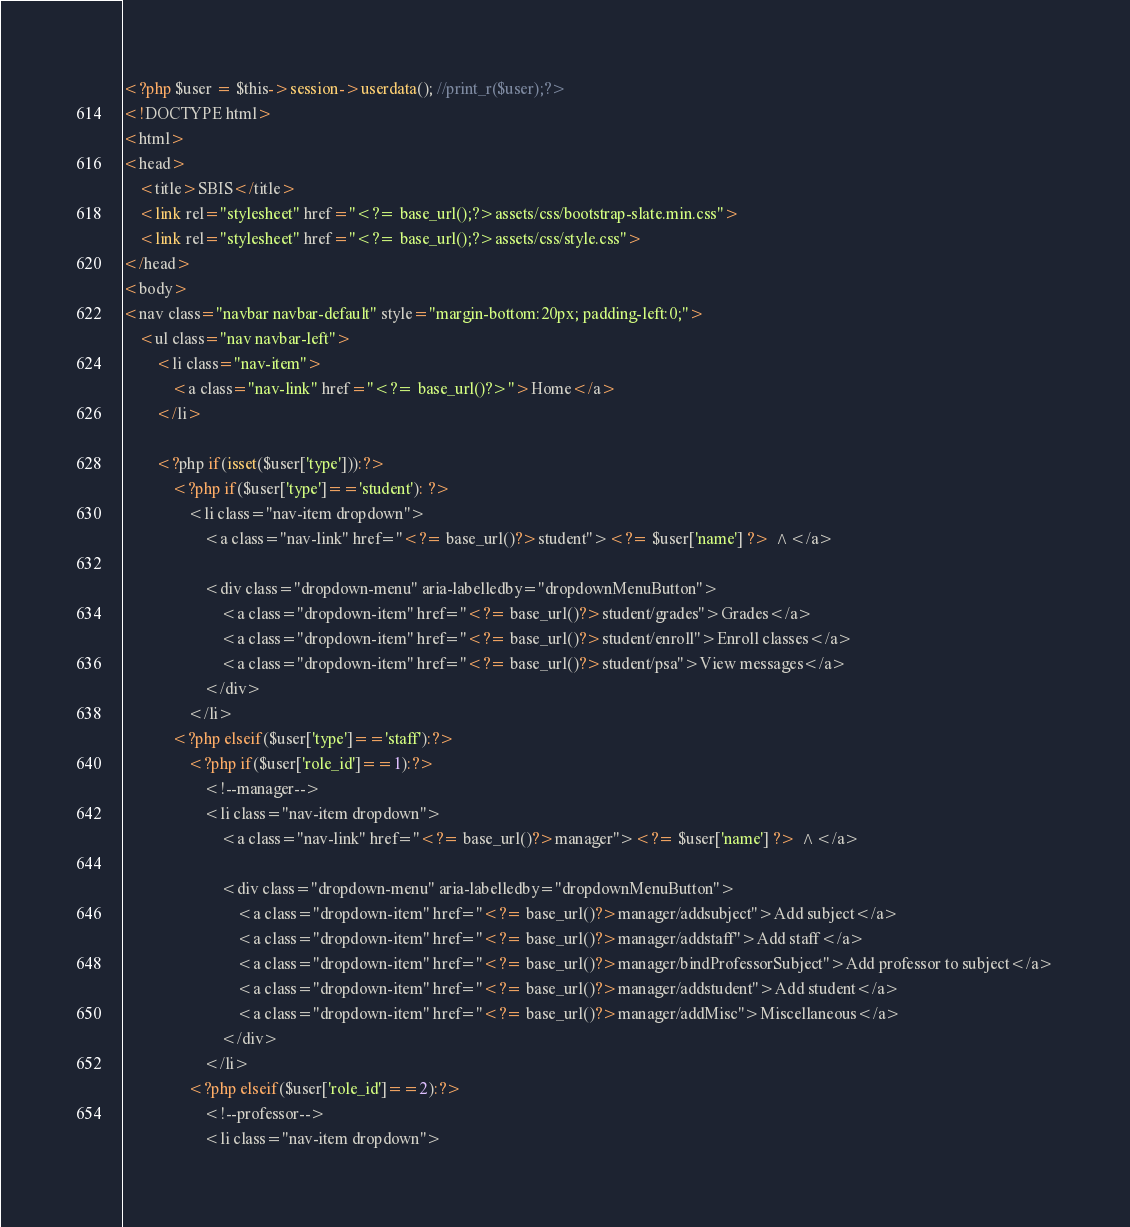Convert code to text. <code><loc_0><loc_0><loc_500><loc_500><_PHP_><?php $user = $this->session->userdata(); //print_r($user);?>
<!DOCTYPE html>
<html>
<head>
	<title>SBIS</title>
	<link rel="stylesheet" href="<?= base_url();?>assets/css/bootstrap-slate.min.css">
	<link rel="stylesheet" href="<?= base_url();?>assets/css/style.css">
</head>
<body>
<nav class="navbar navbar-default" style="margin-bottom:20px; padding-left:0;">
	<ul class="nav navbar-left">
		<li class="nav-item">
			<a class="nav-link" href="<?= base_url()?>">Home</a>
		</li>

		<?php if(isset($user['type'])):?>
		 	<?php if($user['type']=='student'): ?>
				<li class="nav-item dropdown">
					<a class="nav-link" href="<?= base_url()?>student"><?= $user['name'] ?> ^</a>

					<div class="dropdown-menu" aria-labelledby="dropdownMenuButton">
						<a class="dropdown-item" href="<?= base_url()?>student/grades">Grades</a>
						<a class="dropdown-item" href="<?= base_url()?>student/enroll">Enroll classes</a>
						<a class="dropdown-item" href="<?= base_url()?>student/psa">View messages</a>
					</div>
				</li>
			<?php elseif($user['type']=='staff'):?>
				<?php if($user['role_id']==1):?>
					<!--manager-->
					<li class="nav-item dropdown">
						<a class="nav-link" href="<?= base_url()?>manager"><?= $user['name'] ?> ^</a>

						<div class="dropdown-menu" aria-labelledby="dropdownMenuButton">
							<a class="dropdown-item" href="<?= base_url()?>manager/addsubject">Add subject</a>
							<a class="dropdown-item" href="<?= base_url()?>manager/addstaff">Add staff</a>
							<a class="dropdown-item" href="<?= base_url()?>manager/bindProfessorSubject">Add professor to subject</a>
							<a class="dropdown-item" href="<?= base_url()?>manager/addstudent">Add student</a>
							<a class="dropdown-item" href="<?= base_url()?>manager/addMisc">Miscellaneous</a>
						</div>
					</li>
				<?php elseif($user['role_id']==2):?>
					<!--professor-->
					<li class="nav-item dropdown"></code> 